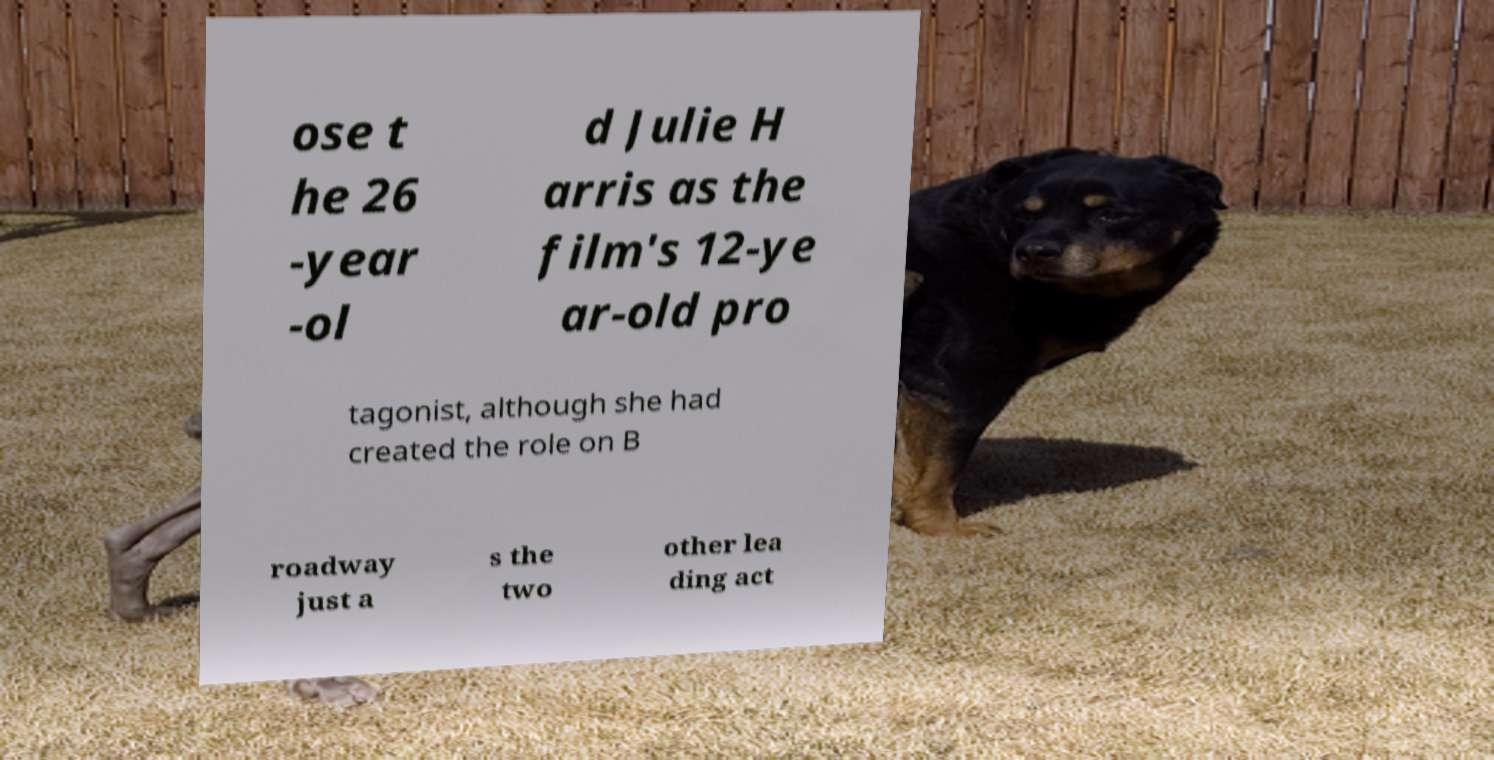Could you assist in decoding the text presented in this image and type it out clearly? ose t he 26 -year -ol d Julie H arris as the film's 12-ye ar-old pro tagonist, although she had created the role on B roadway just a s the two other lea ding act 